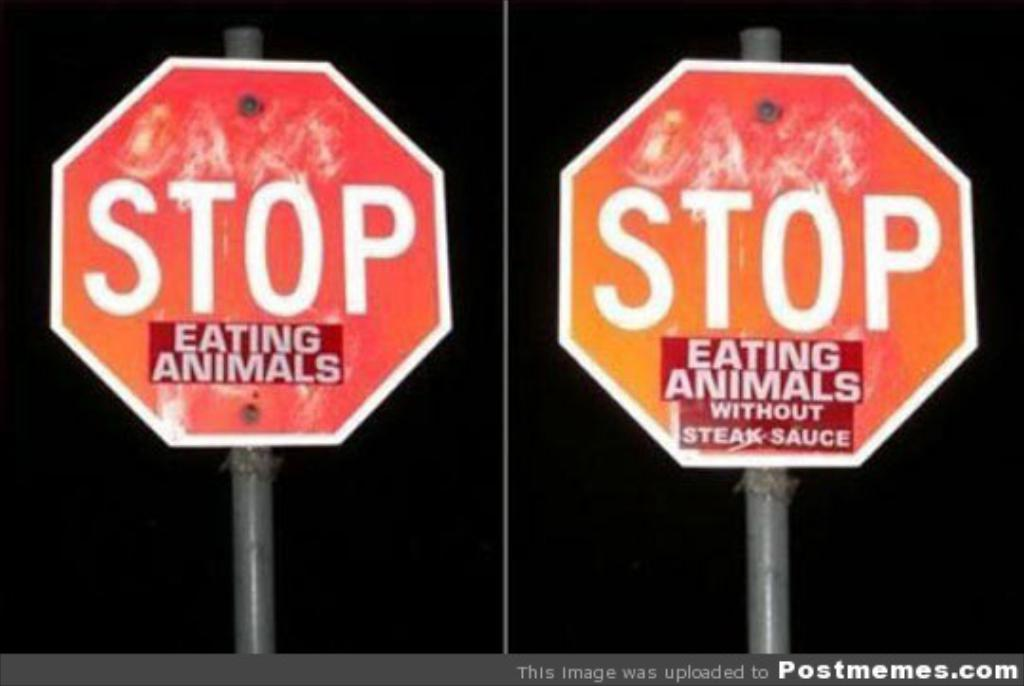Provide a one-sentence caption for the provided image. A red stop sign with a sticker on it that says eating animals. 